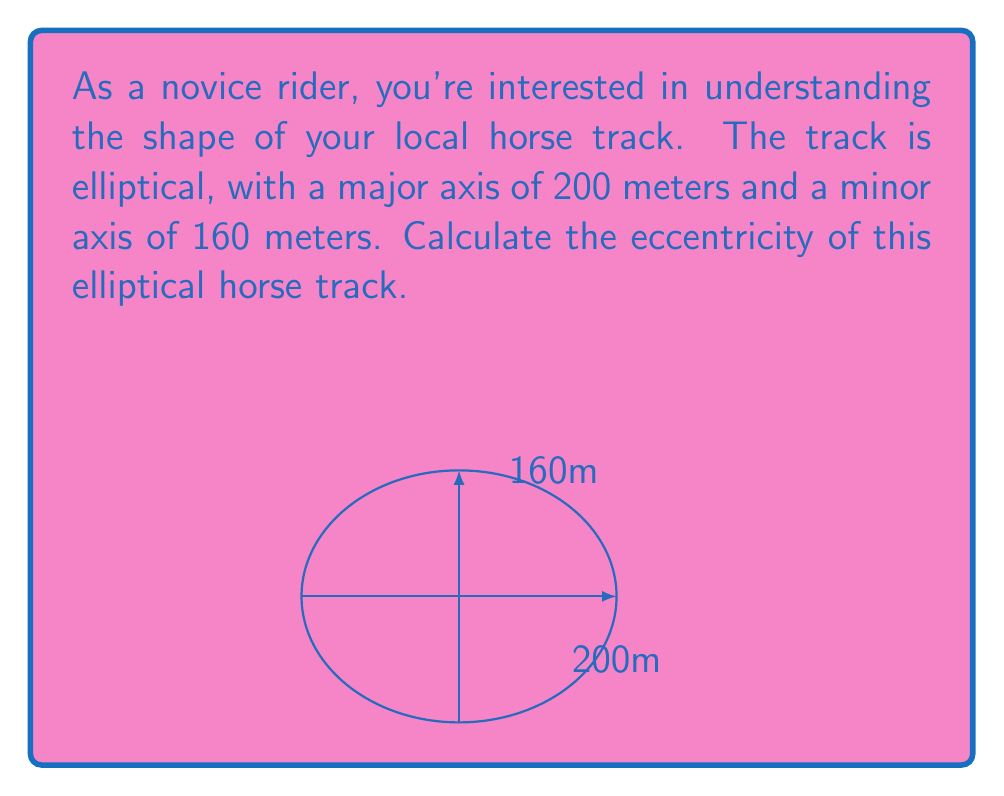Provide a solution to this math problem. To find the eccentricity of an ellipse, we need to follow these steps:

1) Recall the formula for eccentricity:

   $$ e = \sqrt{1 - \frac{b^2}{a^2}} $$

   where $a$ is the semi-major axis and $b$ is the semi-minor axis.

2) Given information:
   - Major axis = 200 meters
   - Minor axis = 160 meters

3) Calculate the semi-major and semi-minor axes:
   $$ a = \frac{200}{2} = 100 \text{ meters} $$
   $$ b = \frac{160}{2} = 80 \text{ meters} $$

4) Substitute these values into the eccentricity formula:

   $$ e = \sqrt{1 - \frac{80^2}{100^2}} $$

5) Simplify:
   $$ e = \sqrt{1 - \frac{6400}{10000}} = \sqrt{1 - 0.64} = \sqrt{0.36} = 0.6 $$

Therefore, the eccentricity of the elliptical horse track is 0.6.
Answer: 0.6 